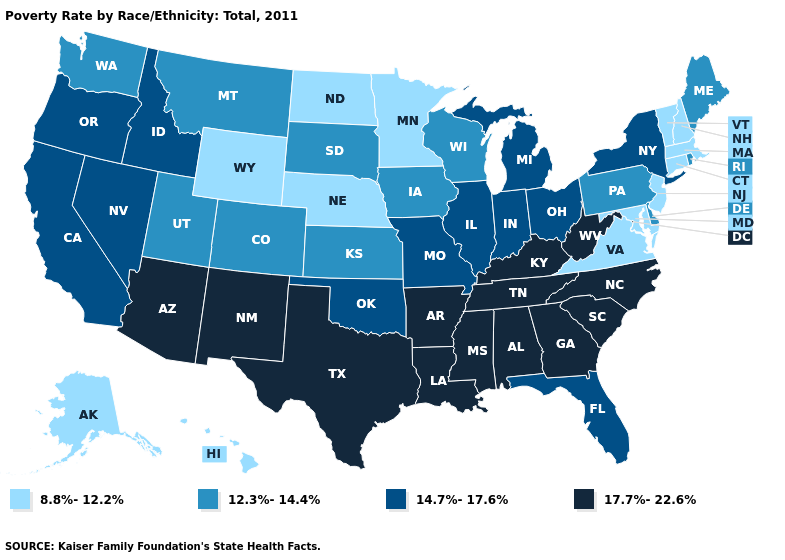What is the value of Arizona?
Give a very brief answer. 17.7%-22.6%. What is the lowest value in the USA?
Short answer required. 8.8%-12.2%. What is the highest value in the USA?
Give a very brief answer. 17.7%-22.6%. What is the value of Nevada?
Concise answer only. 14.7%-17.6%. What is the value of Wisconsin?
Answer briefly. 12.3%-14.4%. What is the highest value in the USA?
Keep it brief. 17.7%-22.6%. Does California have a higher value than Pennsylvania?
Write a very short answer. Yes. Which states have the highest value in the USA?
Quick response, please. Alabama, Arizona, Arkansas, Georgia, Kentucky, Louisiana, Mississippi, New Mexico, North Carolina, South Carolina, Tennessee, Texas, West Virginia. Does New Hampshire have the highest value in the USA?
Keep it brief. No. What is the highest value in the Northeast ?
Write a very short answer. 14.7%-17.6%. What is the value of Mississippi?
Concise answer only. 17.7%-22.6%. What is the value of North Carolina?
Answer briefly. 17.7%-22.6%. Does New Mexico have the highest value in the West?
Be succinct. Yes. Which states have the highest value in the USA?
Short answer required. Alabama, Arizona, Arkansas, Georgia, Kentucky, Louisiana, Mississippi, New Mexico, North Carolina, South Carolina, Tennessee, Texas, West Virginia. 